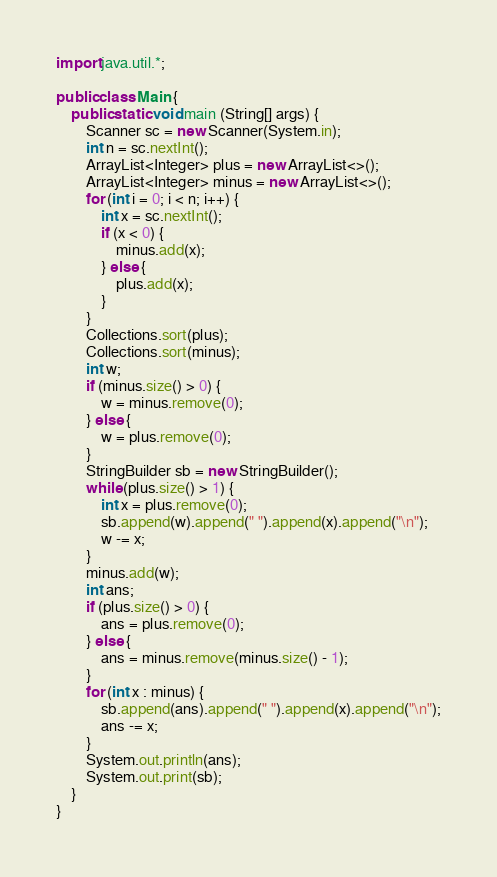<code> <loc_0><loc_0><loc_500><loc_500><_Java_>import java.util.*;

public class Main {
	public static void main (String[] args) {
		Scanner sc = new Scanner(System.in);
		int n = sc.nextInt();
		ArrayList<Integer> plus = new ArrayList<>();
		ArrayList<Integer> minus = new ArrayList<>();
		for (int i = 0; i < n; i++) {
			int x = sc.nextInt();
			if (x < 0) {
				minus.add(x);
			} else {
				plus.add(x);
			}
		}
		Collections.sort(plus);
		Collections.sort(minus);
		int w;
		if (minus.size() > 0) {
			w = minus.remove(0);
		} else {
			w = plus.remove(0);
		}
		StringBuilder sb = new StringBuilder();
		while (plus.size() > 1) {
			int x = plus.remove(0);
			sb.append(w).append(" ").append(x).append("\n");
			w -= x;
		}
		minus.add(w);
		int ans;
		if (plus.size() > 0) {
			ans = plus.remove(0);
		} else {
			ans = minus.remove(minus.size() - 1);
		}
		for (int x : minus) {
			sb.append(ans).append(" ").append(x).append("\n");
			ans -= x;
		}
		System.out.println(ans);
		System.out.print(sb);
	}
}
</code> 